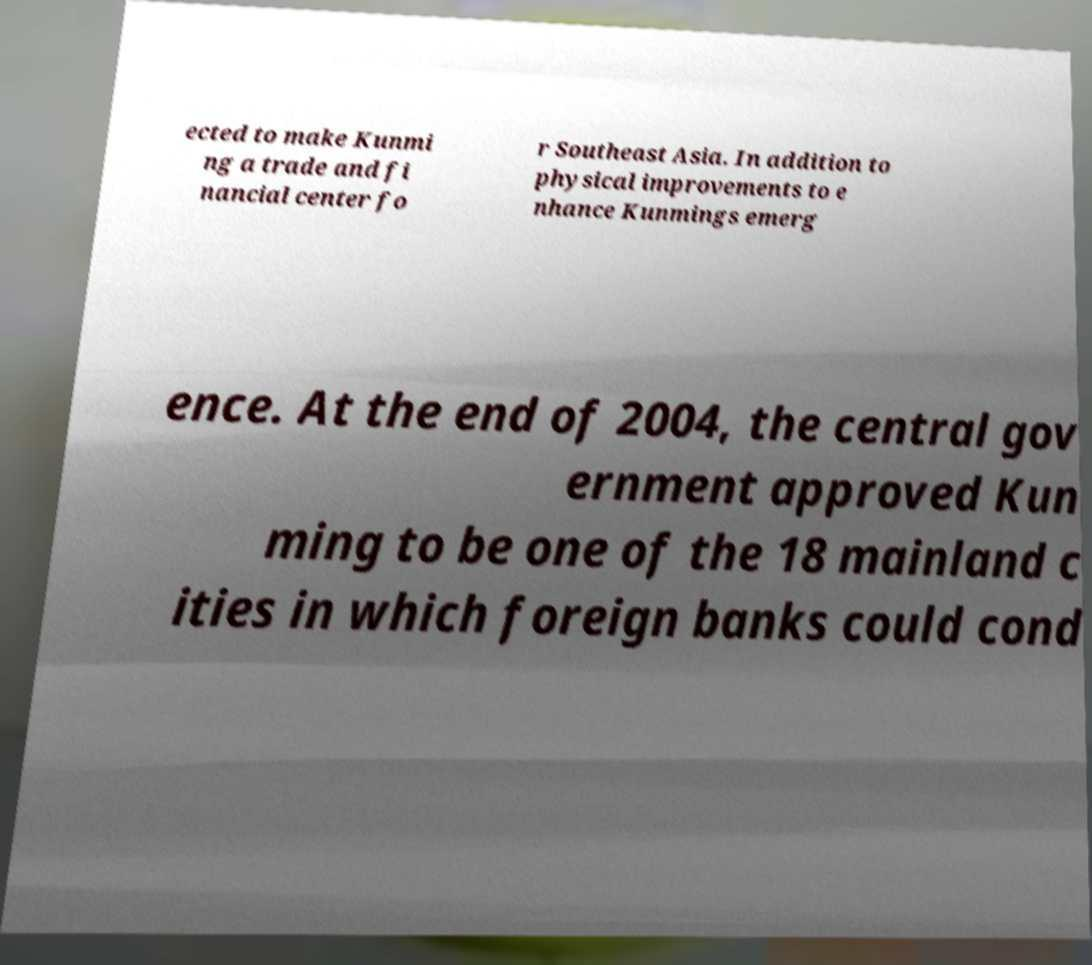Can you read and provide the text displayed in the image?This photo seems to have some interesting text. Can you extract and type it out for me? ected to make Kunmi ng a trade and fi nancial center fo r Southeast Asia. In addition to physical improvements to e nhance Kunmings emerg ence. At the end of 2004, the central gov ernment approved Kun ming to be one of the 18 mainland c ities in which foreign banks could cond 